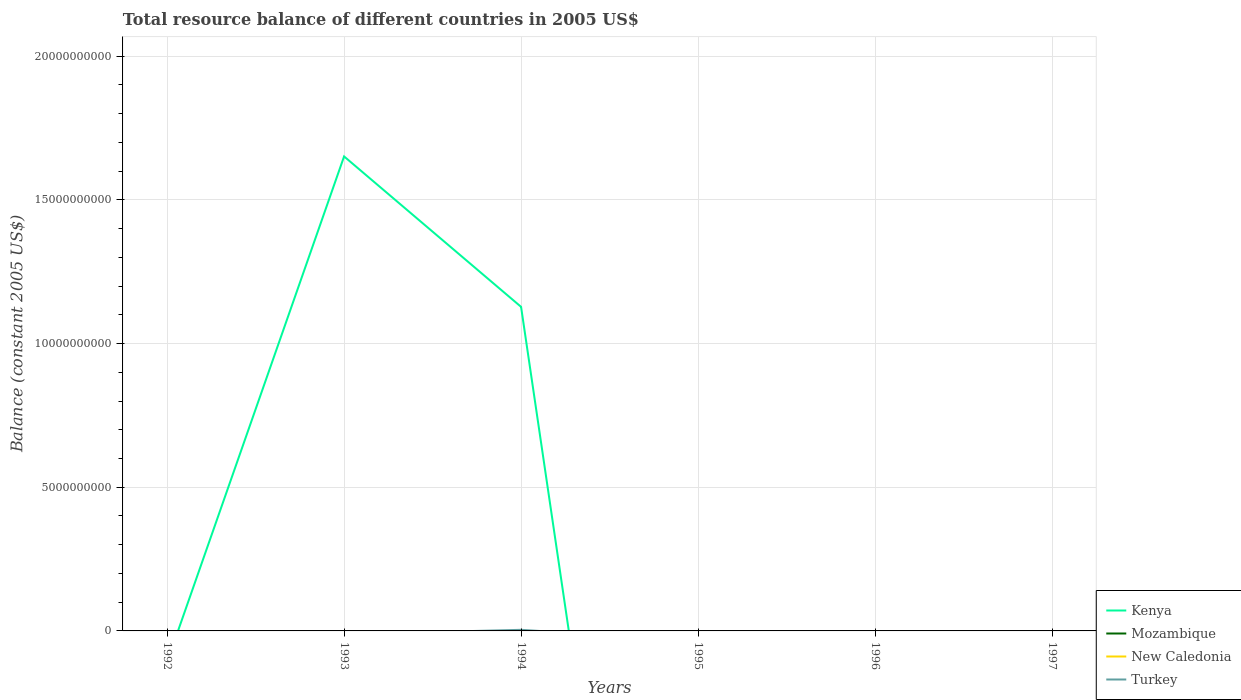Does the line corresponding to Turkey intersect with the line corresponding to Kenya?
Keep it short and to the point. Yes. Is the number of lines equal to the number of legend labels?
Your answer should be compact. No. Across all years, what is the maximum total resource balance in Turkey?
Give a very brief answer. 0. What is the difference between the highest and the second highest total resource balance in Turkey?
Keep it short and to the point. 3.78e+07. What is the difference between the highest and the lowest total resource balance in New Caledonia?
Keep it short and to the point. 0. Is the total resource balance in Kenya strictly greater than the total resource balance in Mozambique over the years?
Ensure brevity in your answer.  No. How many lines are there?
Your answer should be very brief. 2. Are the values on the major ticks of Y-axis written in scientific E-notation?
Ensure brevity in your answer.  No. Does the graph contain any zero values?
Your answer should be compact. Yes. How are the legend labels stacked?
Offer a very short reply. Vertical. What is the title of the graph?
Give a very brief answer. Total resource balance of different countries in 2005 US$. Does "Djibouti" appear as one of the legend labels in the graph?
Offer a very short reply. No. What is the label or title of the Y-axis?
Provide a short and direct response. Balance (constant 2005 US$). What is the Balance (constant 2005 US$) in Kenya in 1992?
Make the answer very short. 0. What is the Balance (constant 2005 US$) of Mozambique in 1992?
Ensure brevity in your answer.  0. What is the Balance (constant 2005 US$) in New Caledonia in 1992?
Your answer should be compact. 0. What is the Balance (constant 2005 US$) in Kenya in 1993?
Keep it short and to the point. 1.65e+1. What is the Balance (constant 2005 US$) of Turkey in 1993?
Provide a short and direct response. 0. What is the Balance (constant 2005 US$) in Kenya in 1994?
Keep it short and to the point. 1.13e+1. What is the Balance (constant 2005 US$) in New Caledonia in 1994?
Your answer should be very brief. 0. What is the Balance (constant 2005 US$) in Turkey in 1994?
Your answer should be compact. 3.78e+07. What is the Balance (constant 2005 US$) of Mozambique in 1995?
Keep it short and to the point. 0. What is the Balance (constant 2005 US$) in Turkey in 1995?
Your answer should be very brief. 0. What is the Balance (constant 2005 US$) of Kenya in 1996?
Offer a terse response. 0. What is the Balance (constant 2005 US$) in Mozambique in 1996?
Provide a short and direct response. 0. What is the Balance (constant 2005 US$) of Turkey in 1996?
Your response must be concise. 0. What is the Balance (constant 2005 US$) in Mozambique in 1997?
Your answer should be compact. 0. What is the Balance (constant 2005 US$) in New Caledonia in 1997?
Keep it short and to the point. 0. Across all years, what is the maximum Balance (constant 2005 US$) of Kenya?
Provide a short and direct response. 1.65e+1. Across all years, what is the maximum Balance (constant 2005 US$) in Turkey?
Ensure brevity in your answer.  3.78e+07. What is the total Balance (constant 2005 US$) of Kenya in the graph?
Your answer should be very brief. 2.78e+1. What is the total Balance (constant 2005 US$) of Mozambique in the graph?
Offer a very short reply. 0. What is the total Balance (constant 2005 US$) of Turkey in the graph?
Offer a very short reply. 3.78e+07. What is the difference between the Balance (constant 2005 US$) in Kenya in 1993 and that in 1994?
Give a very brief answer. 5.23e+09. What is the difference between the Balance (constant 2005 US$) in Kenya in 1993 and the Balance (constant 2005 US$) in Turkey in 1994?
Make the answer very short. 1.65e+1. What is the average Balance (constant 2005 US$) of Kenya per year?
Your response must be concise. 4.63e+09. What is the average Balance (constant 2005 US$) in Turkey per year?
Your answer should be compact. 6.31e+06. In the year 1994, what is the difference between the Balance (constant 2005 US$) of Kenya and Balance (constant 2005 US$) of Turkey?
Make the answer very short. 1.12e+1. What is the ratio of the Balance (constant 2005 US$) in Kenya in 1993 to that in 1994?
Offer a terse response. 1.46. What is the difference between the highest and the lowest Balance (constant 2005 US$) of Kenya?
Your answer should be compact. 1.65e+1. What is the difference between the highest and the lowest Balance (constant 2005 US$) of Turkey?
Offer a very short reply. 3.78e+07. 